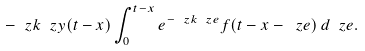Convert formula to latex. <formula><loc_0><loc_0><loc_500><loc_500>- \ z k \ z y ( t - x ) \int _ { 0 } ^ { t - x } e ^ { - \ z k \ z e } f ( t - x - \ z e ) \, d \ z e .</formula> 